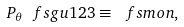Convert formula to latex. <formula><loc_0><loc_0><loc_500><loc_500>P _ { \theta } \, \ f s { g } { u } { 1 } { 2 } { 3 } \equiv \, \ f s m o n ,</formula> 